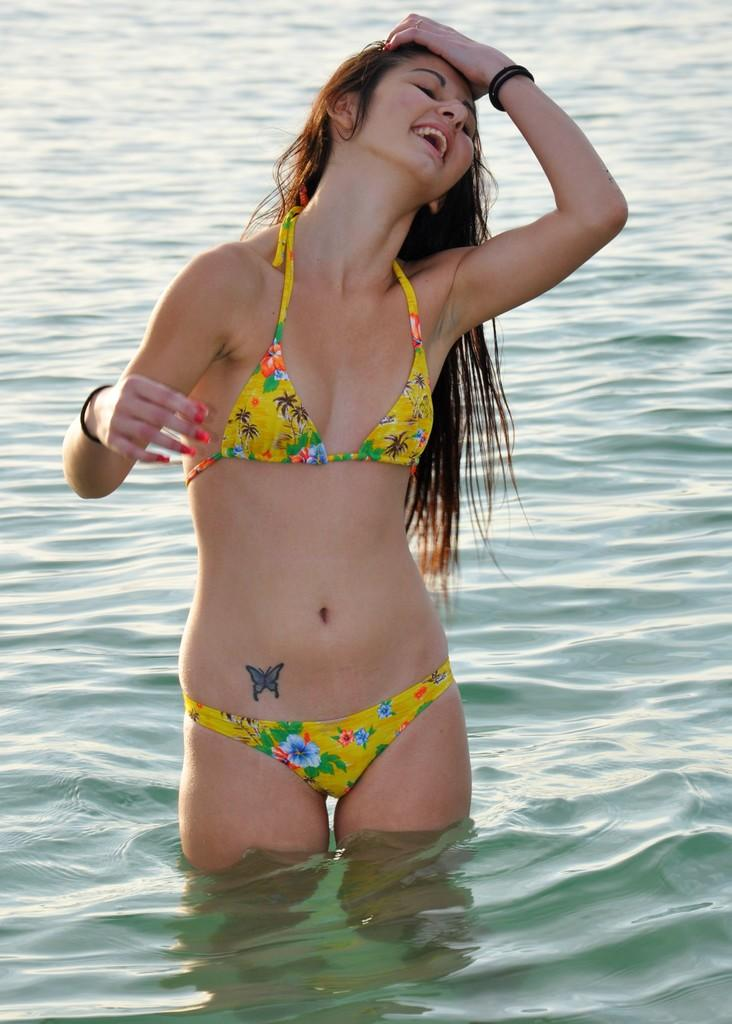Who is present in the image? There is a woman in the image. What is the woman wearing? The woman is wearing a bikini. Where is the woman located in the image? The woman is standing in the water. What type of crime is being committed in the image? There is no indication of a crime being committed in the image. How does the woman feel about the weather in the image? The image does not provide any information about the woman's feelings or the weather. 